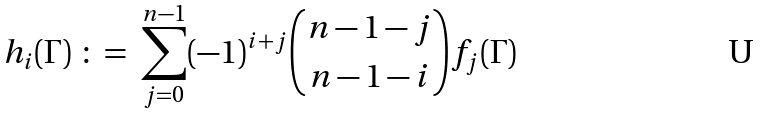Convert formula to latex. <formula><loc_0><loc_0><loc_500><loc_500>h _ { i } ( \Gamma ) \ \colon = \ \sum _ { j = 0 } ^ { n - 1 } ( - 1 ) ^ { i + j } \binom { n - 1 - j } { n - 1 - i } f _ { j } ( \Gamma )</formula> 